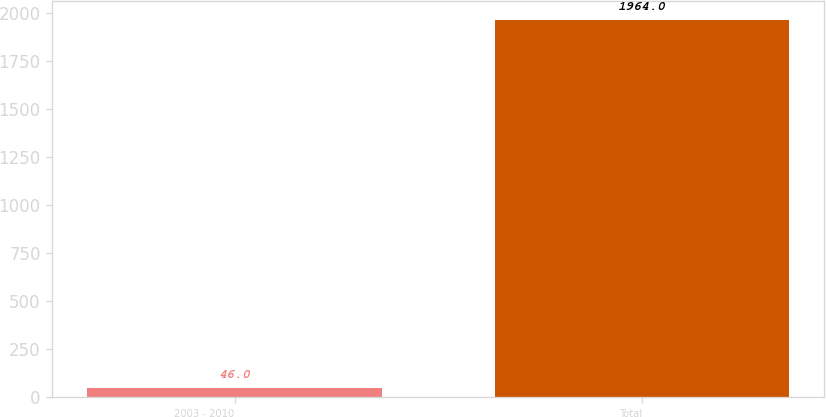<chart> <loc_0><loc_0><loc_500><loc_500><bar_chart><fcel>2003 - 2010<fcel>Total<nl><fcel>46<fcel>1964<nl></chart> 